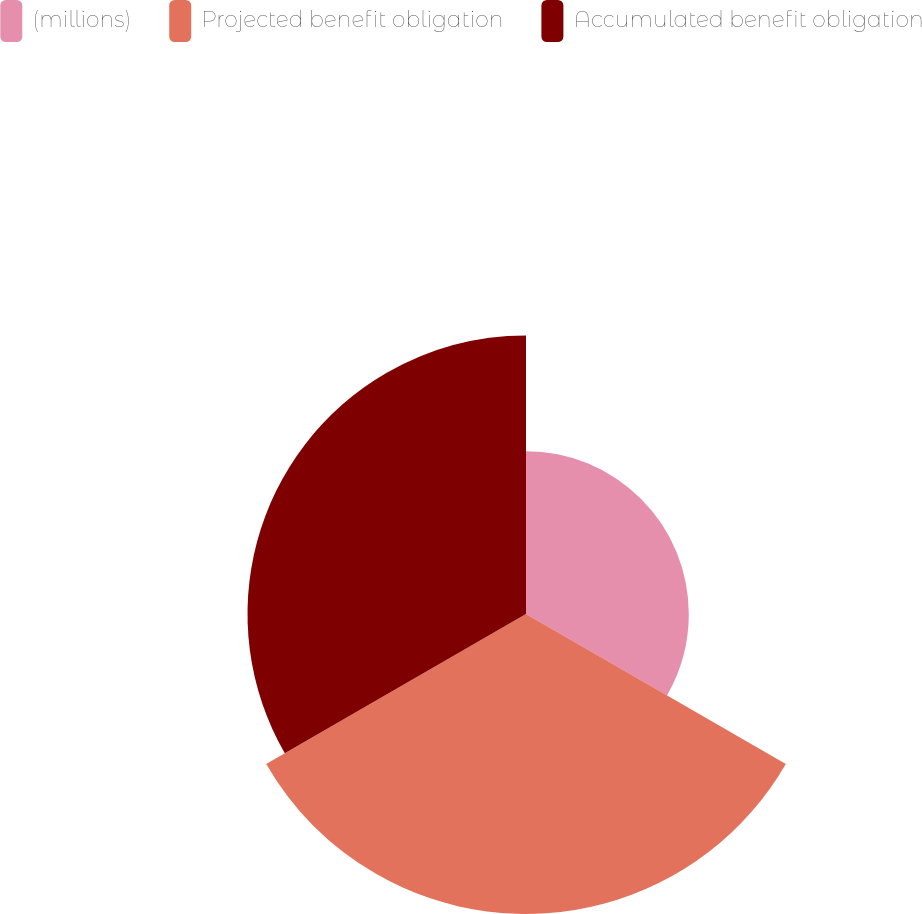Convert chart to OTSL. <chart><loc_0><loc_0><loc_500><loc_500><pie_chart><fcel>(millions)<fcel>Projected benefit obligation<fcel>Accumulated benefit obligation<nl><fcel>21.96%<fcel>40.47%<fcel>37.57%<nl></chart> 